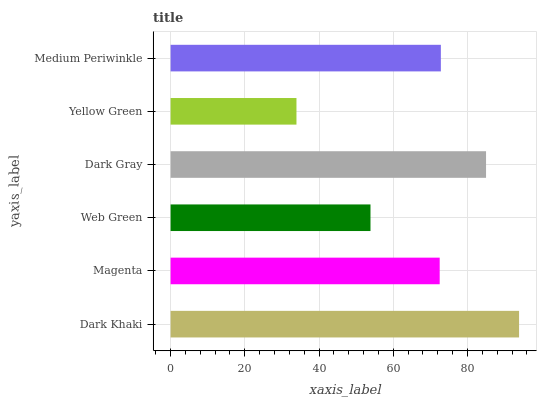Is Yellow Green the minimum?
Answer yes or no. Yes. Is Dark Khaki the maximum?
Answer yes or no. Yes. Is Magenta the minimum?
Answer yes or no. No. Is Magenta the maximum?
Answer yes or no. No. Is Dark Khaki greater than Magenta?
Answer yes or no. Yes. Is Magenta less than Dark Khaki?
Answer yes or no. Yes. Is Magenta greater than Dark Khaki?
Answer yes or no. No. Is Dark Khaki less than Magenta?
Answer yes or no. No. Is Medium Periwinkle the high median?
Answer yes or no. Yes. Is Magenta the low median?
Answer yes or no. Yes. Is Dark Gray the high median?
Answer yes or no. No. Is Yellow Green the low median?
Answer yes or no. No. 